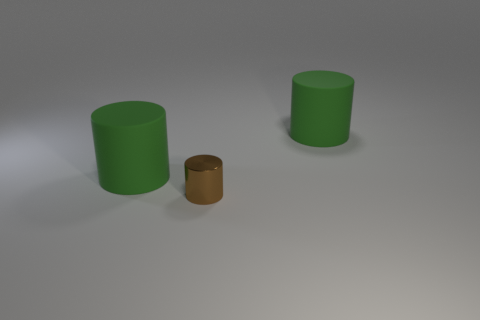Are there any shiny objects on the right side of the small brown metallic object?
Make the answer very short. No. Is the brown cylinder made of the same material as the large cylinder that is to the right of the tiny metallic cylinder?
Ensure brevity in your answer.  No. Is the shape of the object left of the tiny metallic cylinder the same as  the tiny brown metallic thing?
Provide a succinct answer. Yes. What number of green cylinders have the same material as the brown object?
Your answer should be compact. 0. What number of objects are either big green things that are to the right of the brown thing or red cylinders?
Provide a succinct answer. 1. What is the size of the brown cylinder?
Make the answer very short. Small. There is a green cylinder that is in front of the rubber object on the right side of the small brown metallic object; what is it made of?
Offer a terse response. Rubber. Does the matte cylinder to the right of the brown object have the same size as the metal cylinder?
Ensure brevity in your answer.  No. Are there any large rubber cylinders of the same color as the metallic thing?
Your response must be concise. No. How many things are green matte cylinders right of the tiny brown shiny object or green rubber cylinders that are on the left side of the small brown metallic object?
Provide a short and direct response. 2. 